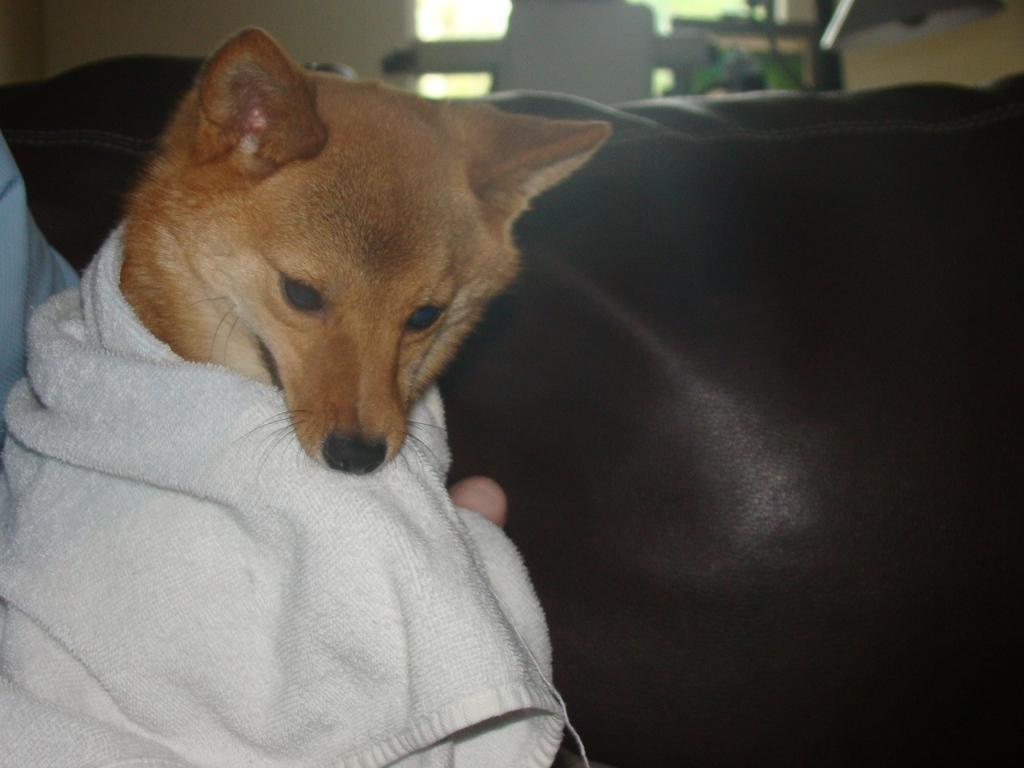Could you give a brief overview of what you see in this image? In this image, we can see a dog wearing a towel. There is a sofa in the middle of the image. 